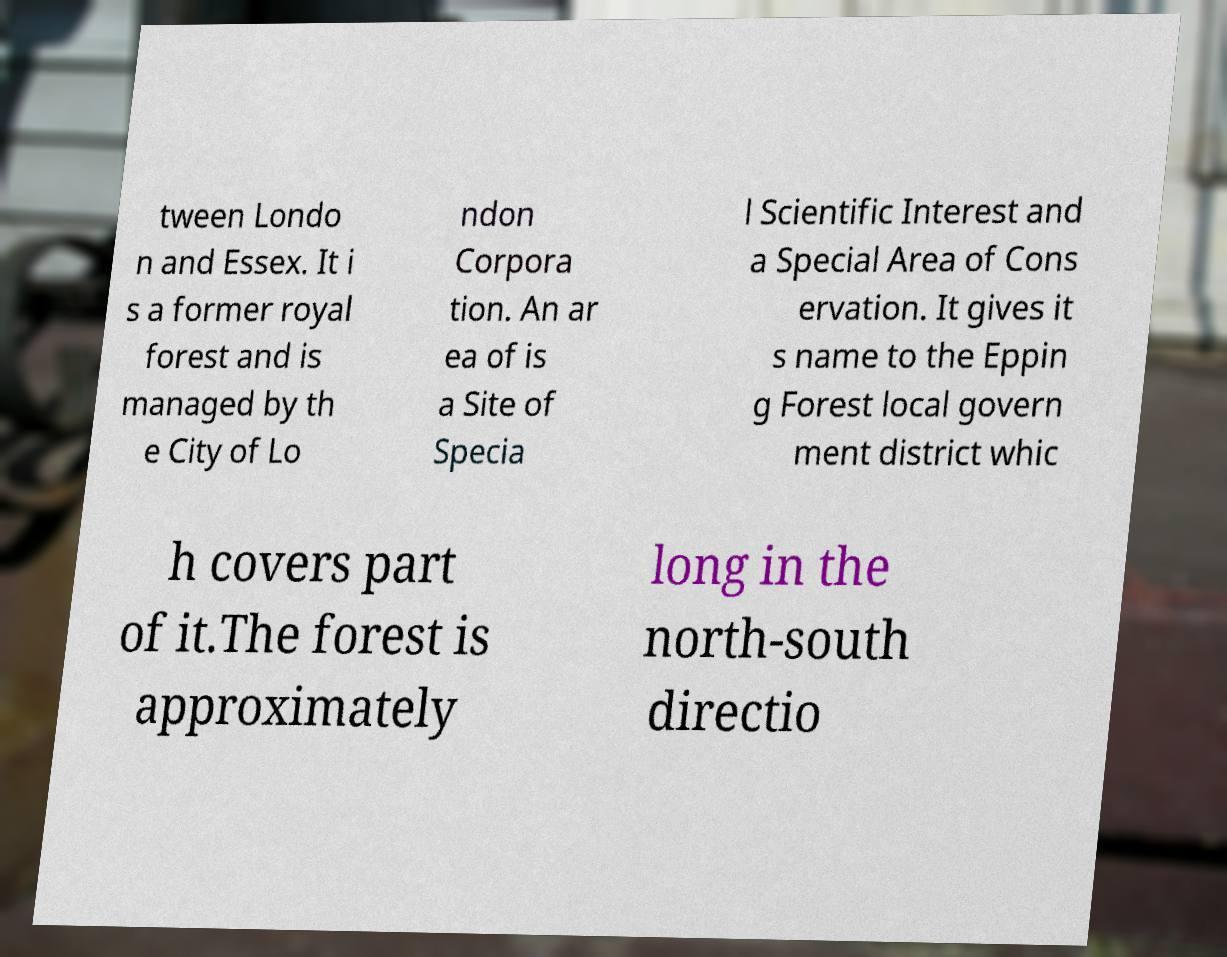There's text embedded in this image that I need extracted. Can you transcribe it verbatim? tween Londo n and Essex. It i s a former royal forest and is managed by th e City of Lo ndon Corpora tion. An ar ea of is a Site of Specia l Scientific Interest and a Special Area of Cons ervation. It gives it s name to the Eppin g Forest local govern ment district whic h covers part of it.The forest is approximately long in the north-south directio 